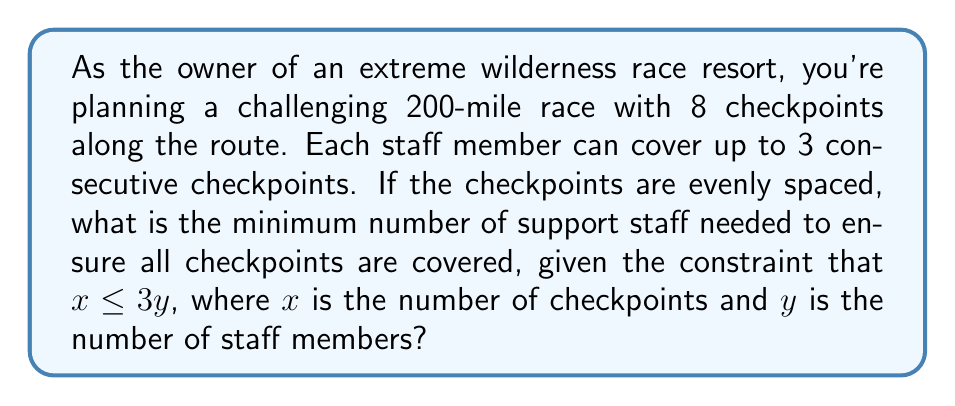Provide a solution to this math problem. Let's approach this step-by-step:

1) We have 8 checkpoints in total, so $x = 8$.

2) We're given the inequality $x \leq 3y$, where $y$ is the number of staff members.

3) Substituting $x = 8$, we get:

   $8 \leq 3y$

4) To find the minimum number of staff, we need to solve this inequality:

   $\frac{8}{3} \leq y$

5) Since $y$ represents the number of staff members, it must be a whole number. Therefore, we need to round up $\frac{8}{3}$ to the nearest integer.

6) $\frac{8}{3} \approx 2.67$

7) Rounding up, we get $y \geq 3$

Therefore, the minimum number of staff members needed is 3.

To verify:
- With 3 staff members, we can cover up to $3 \times 3 = 9$ checkpoints.
- This is sufficient to cover all 8 checkpoints in our race.

If we used only 2 staff members, they could cover at most $2 \times 3 = 6$ checkpoints, which is not enough for our 8-checkpoint race.
Answer: The minimum number of support staff needed is 3. 